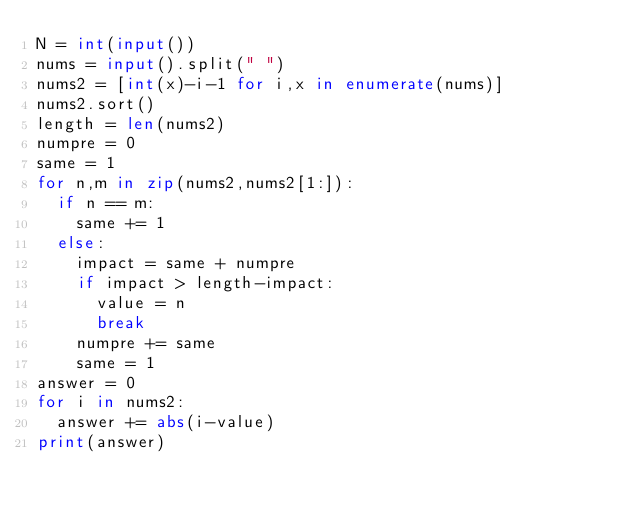Convert code to text. <code><loc_0><loc_0><loc_500><loc_500><_Python_>N = int(input())
nums = input().split(" ")
nums2 = [int(x)-i-1 for i,x in enumerate(nums)]
nums2.sort()
length = len(nums2)
numpre = 0
same = 1
for n,m in zip(nums2,nums2[1:]):
  if n == m:
    same += 1
  else:
    impact = same + numpre
    if impact > length-impact:
      value = n
      break
    numpre += same
    same = 1
answer = 0
for i in nums2:
  answer += abs(i-value)
print(answer)</code> 